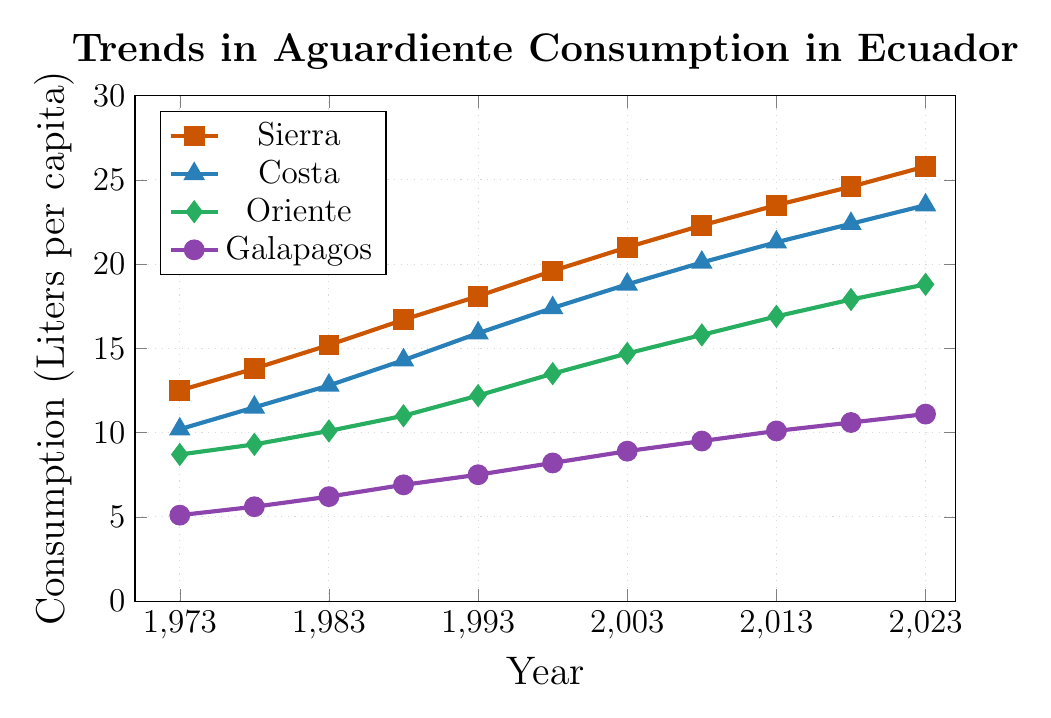What is the trend in the consumption of aguardiente in the Sierra region over the past 50 years? To observe the trend, look at the graph for Sierra (represented by a line with square marks). Note that it consistently increases each year, signifying a rising trend over the 50 years.
Answer: Rising trend Which region had the lowest consumption of aguardiente in 1973? Compare the starting points of all four lines at the year 1973. The Galapagos region, with a value of 5.1, is the lowest.
Answer: Galapagos How much did the consumption of aguardiente in the Costa region increase from 1973 to 2023? Look at the consumption values for Costa in 1973 (10.2) and 2023 (23.5). The increase is calculated by subtracting the 1973 value from the 2023 value: 23.5 - 10.2 = 13.3.
Answer: 13.3 In which year did Oriente first surpass 15 liters per capita consumption? Find the point on the Oriente line (represented by a diamond mark) that first exceeds 15. This occurs in 2008.
Answer: 2008 Which region has the steepest increase in the consumption of aguardiente over the given period? Compare the slopes of all four trend lines. Sierra shows the steepest increase, going from 12.5 in 1973 to 25.8 in 2023, which is the largest overall increase.
Answer: Sierra What is the average consumption of aguardiente in the Galapagos region over the past 50 years? Add consumption values for Galapagos (5.1, 5.6, 6.2, 6.9, 7.5, 8.2, 8.9, 9.5, 10.1, 10.6, 11.1) and divide by the number of data points (11). \( \text{Sum} = 89.7 \), and \( \text{Average} = 89.7 / 11 \approx 8.15 \).
Answer: 8.15 Which region had the highest consumption of aguardiente in 2018? Compare the values for all regions in the year 2018. Sierra, with a value of 24.6, is the highest.
Answer: Sierra How many regions had a consumption value greater than 20 liters per capita in 2023? Check the consumption values for all regions in 2023. Sierra (25.8) and Costa (23.5) both have values greater than 20, totaling 2 regions.
Answer: 2 regions What is the difference in consumption between Oriente and Costa in 1993? Subtract the consumption value of Oriente in 1993 (12.2) from that of Costa (15.9). 15.9 - 12.2 = 3.7.
Answer: 3.7 Which two regions had the closest consumption values in 1988? Compare the values for all four regions in 1988. Costa (14.3) and Oriente (11.0) have a difference of 3.3, which is the closest compared to other pairs.
Answer: Costa and Oriente 